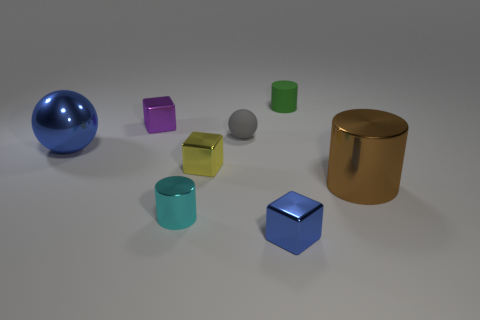What color is the metallic cylinder that is on the left side of the blue thing right of the tiny cylinder that is in front of the small gray object?
Provide a succinct answer. Cyan. There is a large thing on the right side of the blue shiny sphere; is its shape the same as the cyan object?
Give a very brief answer. Yes. What is the small gray ball made of?
Ensure brevity in your answer.  Rubber. There is a blue object in front of the big object that is right of the blue object on the left side of the tiny sphere; what is its shape?
Give a very brief answer. Cube. What number of other things are there of the same shape as the big blue shiny thing?
Your answer should be very brief. 1. There is a rubber sphere; is it the same color as the shiny cylinder that is on the left side of the yellow thing?
Your answer should be very brief. No. How many small gray metallic cylinders are there?
Ensure brevity in your answer.  0. What number of objects are either tiny yellow shiny blocks or tiny metal blocks?
Your response must be concise. 3. There is a metallic cube that is the same color as the big shiny ball; what is its size?
Provide a short and direct response. Small. Are there any blue objects behind the brown metallic cylinder?
Your answer should be compact. Yes. 